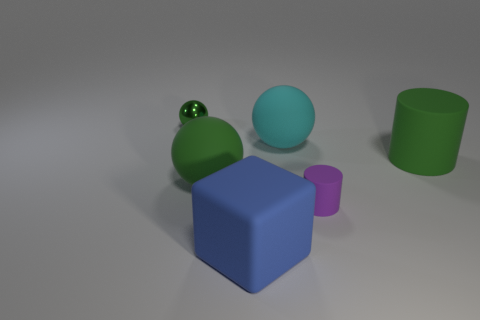Subtract all red cubes. How many green balls are left? 2 Subtract 1 balls. How many balls are left? 2 Subtract all big matte spheres. How many spheres are left? 1 Add 1 big cyan rubber balls. How many objects exist? 7 Subtract all cylinders. How many objects are left? 4 Subtract all purple spheres. Subtract all brown blocks. How many spheres are left? 3 Subtract 0 blue cylinders. How many objects are left? 6 Subtract all tiny brown matte cubes. Subtract all cylinders. How many objects are left? 4 Add 1 large cyan objects. How many large cyan objects are left? 2 Add 6 large cylinders. How many large cylinders exist? 7 